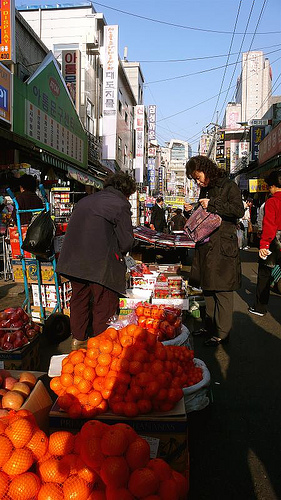Please provide a short description for this region: [0.58, 0.4, 0.6, 0.43]. The observed segment accurately captures a human hand, which could be interacting with another person or object, typically seen in busy market interactions. 